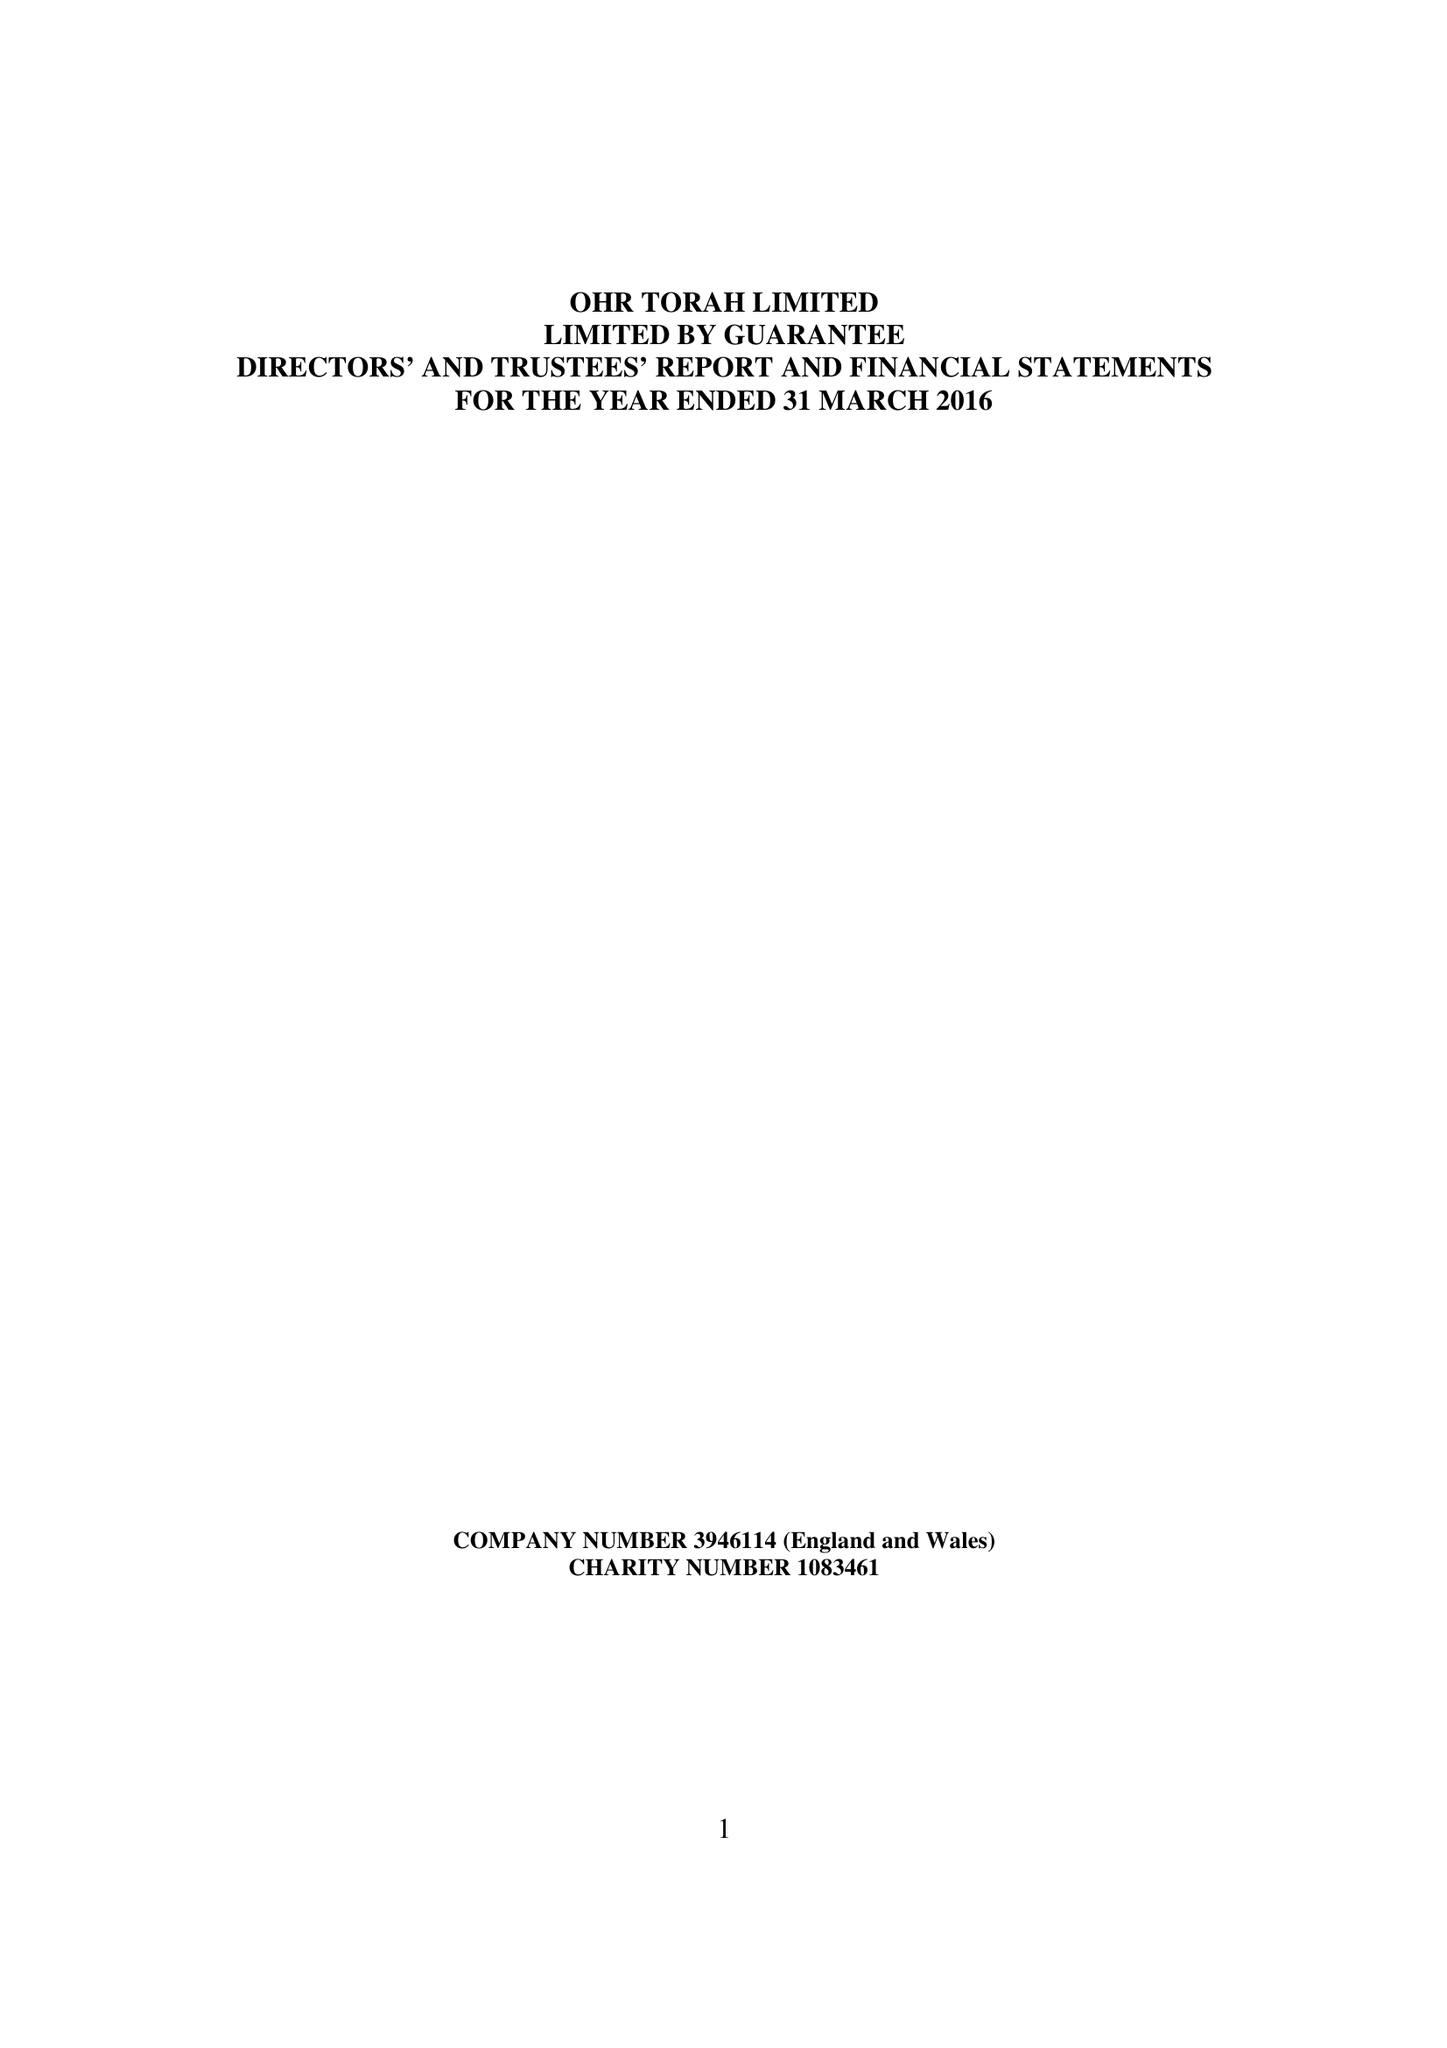What is the value for the spending_annually_in_british_pounds?
Answer the question using a single word or phrase. 68300.00 